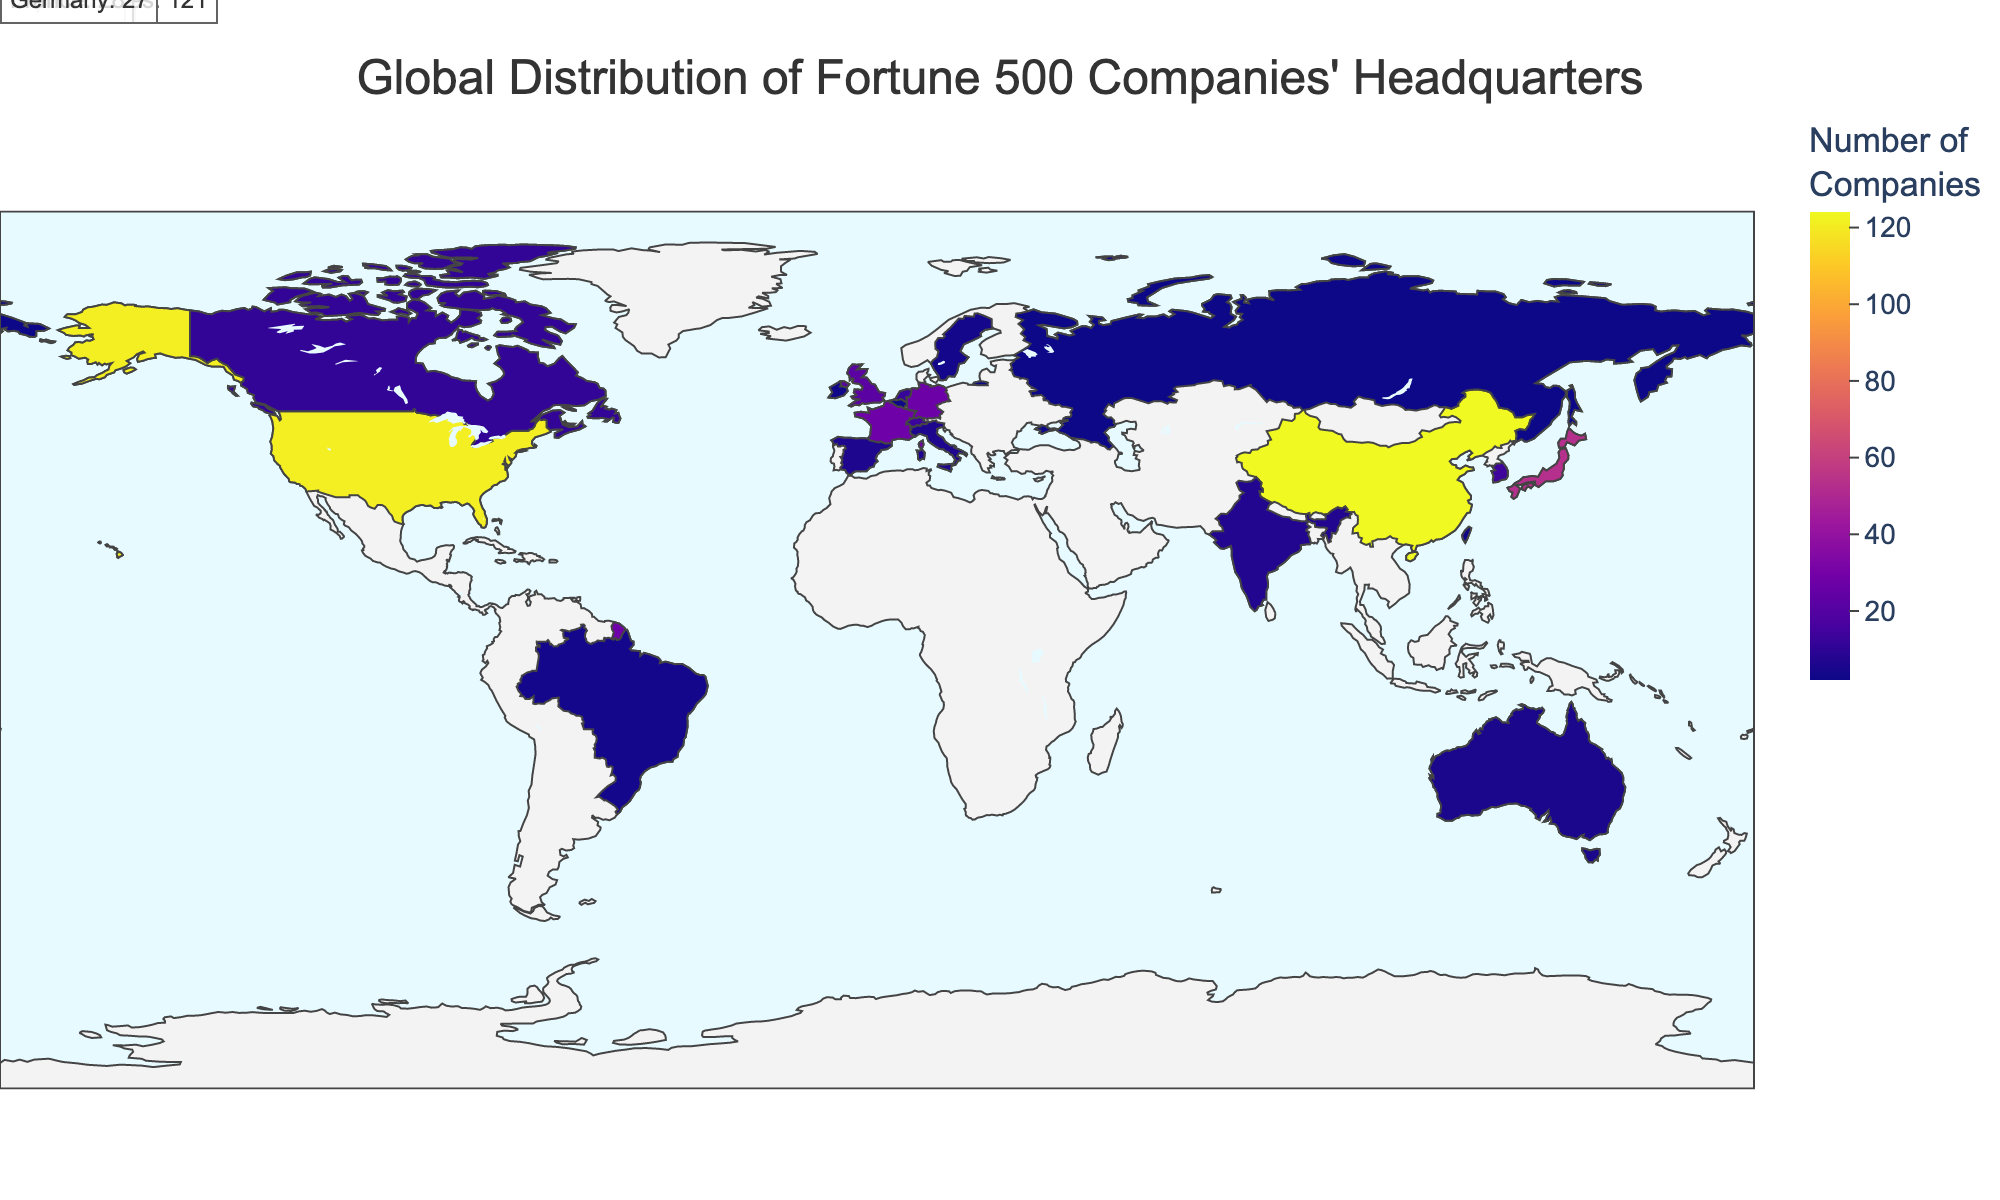What is the title of the figure? The title is usually displayed prominently at the top of the figure. It provides a summary of what the figure is about. The title of this figure is "Global Distribution of Fortune 500 Companies' Headquarters".
Answer: Global Distribution of Fortune 500 Companies' Headquarters Which country has the highest number of Fortune 500 companies' headquarters? By looking at the color intensity and annotations on the map, the country with the highest number of headquarters should be clear. China has the highest number with 124 companies.
Answer: China How many Fortune 500 companies' headquarters are there in the United States and Germany combined? From the data, the United States has 121 headquarters and Germany has 27. Adding these together gives 121 + 27 = 148.
Answer: 148 What is the difference in the number of Fortune 500 companies' headquarters between China and Japan? China has 124 headquarters, while Japan has 53. Subtracting these two gives 124 - 53 = 71.
Answer: 71 Which two countries have an equal number of Fortune 500 companies' headquarters? By observing the data, we note that Italy and Spain both have 6 Fortune 500 headquarters.
Answer: Italy and Spain What is the color scheme used for the map? The color scheme is described as "Plasma" in the data, which typically ranges from dark purple to bright yellow.
Answer: Plasma Which continent has the most Fortune 500 companies' headquarters? By observing the geographic distribution, Asia, with major contributors being China (124), Japan (53), and South Korea (14), accounts for the highest count of headquarters.
Answer: Asia How many countries have exactly three Fortune 500 companies' headquarters? By inspecting the data, Taiwan and Ireland are the countries that each have exactly three Fortune 500 companies' headquarters.
Answer: 2 Which country in Europe has the fourth highest number of Fortune 500 companies' headquarters? From the data for Europe, France (28), Germany (27), the United Kingdom (22), and Switzerland (13) are the top, with Switzerland having the fourth-highest number.
Answer: Switzerland 